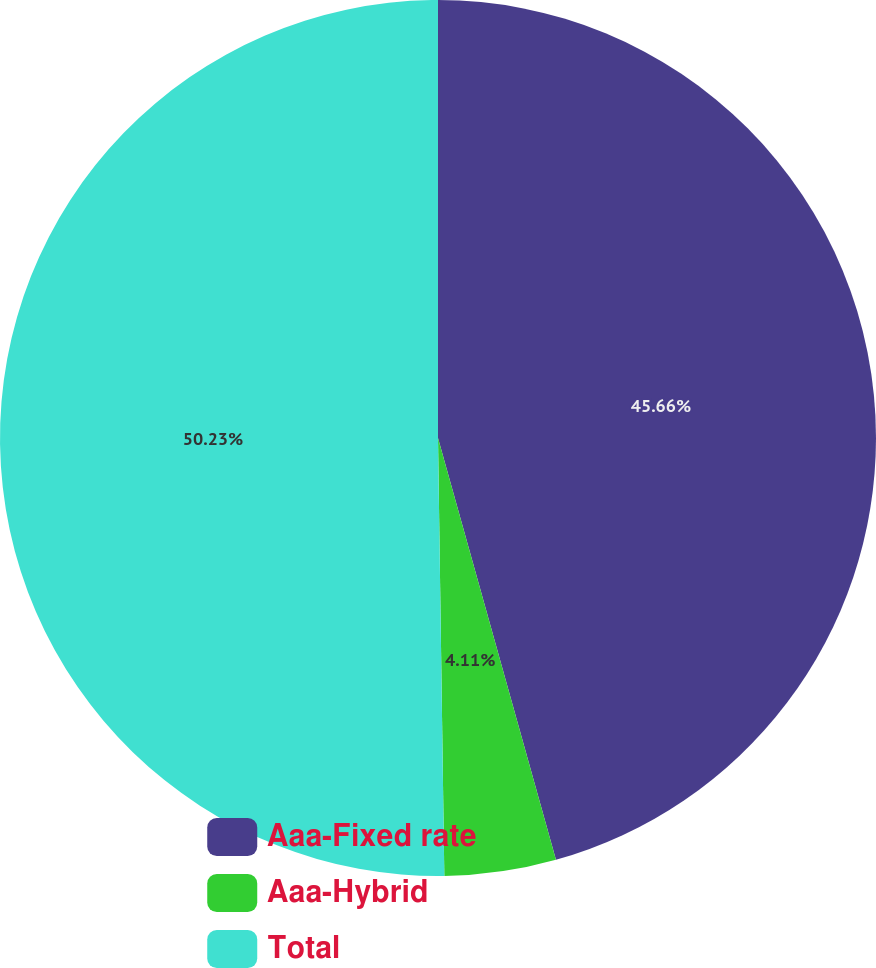Convert chart. <chart><loc_0><loc_0><loc_500><loc_500><pie_chart><fcel>Aaa-Fixed rate<fcel>Aaa-Hybrid<fcel>Total<nl><fcel>45.66%<fcel>4.11%<fcel>50.23%<nl></chart> 